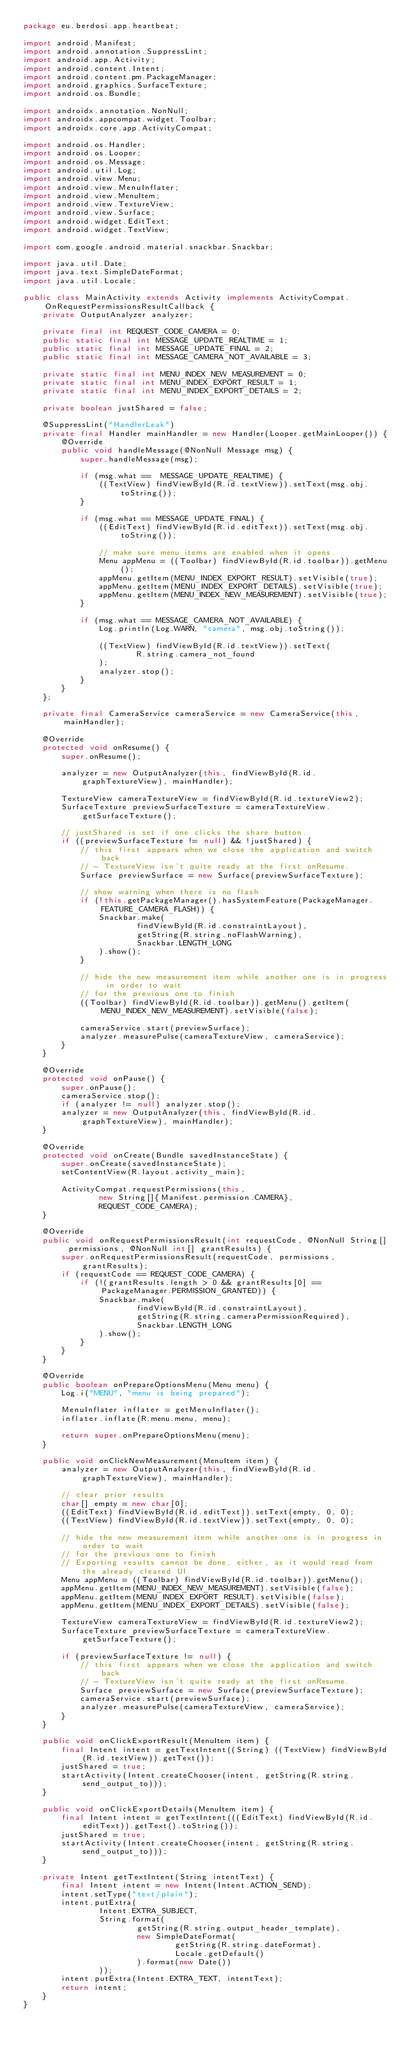<code> <loc_0><loc_0><loc_500><loc_500><_Java_>package eu.berdosi.app.heartbeat;

import android.Manifest;
import android.annotation.SuppressLint;
import android.app.Activity;
import android.content.Intent;
import android.content.pm.PackageManager;
import android.graphics.SurfaceTexture;
import android.os.Bundle;

import androidx.annotation.NonNull;
import androidx.appcompat.widget.Toolbar;
import androidx.core.app.ActivityCompat;

import android.os.Handler;
import android.os.Looper;
import android.os.Message;
import android.util.Log;
import android.view.Menu;
import android.view.MenuInflater;
import android.view.MenuItem;
import android.view.TextureView;
import android.view.Surface;
import android.widget.EditText;
import android.widget.TextView;

import com.google.android.material.snackbar.Snackbar;

import java.util.Date;
import java.text.SimpleDateFormat;
import java.util.Locale;

public class MainActivity extends Activity implements ActivityCompat.OnRequestPermissionsResultCallback {
    private OutputAnalyzer analyzer;

    private final int REQUEST_CODE_CAMERA = 0;
    public static final int MESSAGE_UPDATE_REALTIME = 1;
    public static final int MESSAGE_UPDATE_FINAL = 2;
    public static final int MESSAGE_CAMERA_NOT_AVAILABLE = 3;

    private static final int MENU_INDEX_NEW_MEASUREMENT = 0;
    private static final int MENU_INDEX_EXPORT_RESULT = 1;
    private static final int MENU_INDEX_EXPORT_DETAILS = 2;

    private boolean justShared = false;

    @SuppressLint("HandlerLeak")
    private final Handler mainHandler = new Handler(Looper.getMainLooper()) {
        @Override
        public void handleMessage(@NonNull Message msg) {
            super.handleMessage(msg);

            if (msg.what ==  MESSAGE_UPDATE_REALTIME) {
                ((TextView) findViewById(R.id.textView)).setText(msg.obj.toString());
            }

            if (msg.what == MESSAGE_UPDATE_FINAL) {
                ((EditText) findViewById(R.id.editText)).setText(msg.obj.toString());

                // make sure menu items are enabled when it opens.
                Menu appMenu = ((Toolbar) findViewById(R.id.toolbar)).getMenu();
                appMenu.getItem(MENU_INDEX_EXPORT_RESULT).setVisible(true);
                appMenu.getItem(MENU_INDEX_EXPORT_DETAILS).setVisible(true);
                appMenu.getItem(MENU_INDEX_NEW_MEASUREMENT).setVisible(true);
            }

            if (msg.what == MESSAGE_CAMERA_NOT_AVAILABLE) {
                Log.println(Log.WARN, "camera", msg.obj.toString());

                ((TextView) findViewById(R.id.textView)).setText(
                        R.string.camera_not_found
                );
                analyzer.stop();
            }
        }
    };

    private final CameraService cameraService = new CameraService(this, mainHandler);

    @Override
    protected void onResume() {
        super.onResume();

        analyzer = new OutputAnalyzer(this, findViewById(R.id.graphTextureView), mainHandler);

        TextureView cameraTextureView = findViewById(R.id.textureView2);
        SurfaceTexture previewSurfaceTexture = cameraTextureView.getSurfaceTexture();

        // justShared is set if one clicks the share button.
        if ((previewSurfaceTexture != null) && !justShared) {
            // this first appears when we close the application and switch back
            // - TextureView isn't quite ready at the first onResume.
            Surface previewSurface = new Surface(previewSurfaceTexture);

            // show warning when there is no flash
            if (!this.getPackageManager().hasSystemFeature(PackageManager.FEATURE_CAMERA_FLASH)) {
                Snackbar.make(
                        findViewById(R.id.constraintLayout),
                        getString(R.string.noFlashWarning),
                        Snackbar.LENGTH_LONG
                ).show();
            }

            // hide the new measurement item while another one is in progress in order to wait
            // for the previous one to finish
            ((Toolbar) findViewById(R.id.toolbar)).getMenu().getItem(MENU_INDEX_NEW_MEASUREMENT).setVisible(false);

            cameraService.start(previewSurface);
            analyzer.measurePulse(cameraTextureView, cameraService);
        }
    }

    @Override
    protected void onPause() {
        super.onPause();
        cameraService.stop();
        if (analyzer != null) analyzer.stop();
        analyzer = new OutputAnalyzer(this, findViewById(R.id.graphTextureView), mainHandler);
    }

    @Override
    protected void onCreate(Bundle savedInstanceState) {
        super.onCreate(savedInstanceState);
        setContentView(R.layout.activity_main);

        ActivityCompat.requestPermissions(this,
                new String[]{Manifest.permission.CAMERA},
                REQUEST_CODE_CAMERA);
    }

    @Override
    public void onRequestPermissionsResult(int requestCode, @NonNull String[] permissions, @NonNull int[] grantResults) {
        super.onRequestPermissionsResult(requestCode, permissions, grantResults);
        if (requestCode == REQUEST_CODE_CAMERA) {
            if (!(grantResults.length > 0 && grantResults[0] == PackageManager.PERMISSION_GRANTED)) {
                Snackbar.make(
                        findViewById(R.id.constraintLayout),
                        getString(R.string.cameraPermissionRequired),
                        Snackbar.LENGTH_LONG
                ).show();
            }
        }
    }

    @Override
    public boolean onPrepareOptionsMenu(Menu menu) {
        Log.i("MENU", "menu is being prepared");

        MenuInflater inflater = getMenuInflater();
        inflater.inflate(R.menu.menu, menu);

        return super.onPrepareOptionsMenu(menu);
    }

    public void onClickNewMeasurement(MenuItem item) {
        analyzer = new OutputAnalyzer(this, findViewById(R.id.graphTextureView), mainHandler);

        // clear prior results
        char[] empty = new char[0];
        ((EditText) findViewById(R.id.editText)).setText(empty, 0, 0);
        ((TextView) findViewById(R.id.textView)).setText(empty, 0, 0);

        // hide the new measurement item while another one is in progress in order to wait
        // for the previous one to finish
        // Exporting results cannot be done, either, as it would read from the already cleared UI.
        Menu appMenu = ((Toolbar) findViewById(R.id.toolbar)).getMenu();
        appMenu.getItem(MENU_INDEX_NEW_MEASUREMENT).setVisible(false);
        appMenu.getItem(MENU_INDEX_EXPORT_RESULT).setVisible(false);
        appMenu.getItem(MENU_INDEX_EXPORT_DETAILS).setVisible(false);

        TextureView cameraTextureView = findViewById(R.id.textureView2);
        SurfaceTexture previewSurfaceTexture = cameraTextureView.getSurfaceTexture();

        if (previewSurfaceTexture != null) {
            // this first appears when we close the application and switch back
            // - TextureView isn't quite ready at the first onResume.
            Surface previewSurface = new Surface(previewSurfaceTexture);
            cameraService.start(previewSurface);
            analyzer.measurePulse(cameraTextureView, cameraService);
        }
    }

    public void onClickExportResult(MenuItem item) {
        final Intent intent = getTextIntent((String) ((TextView) findViewById(R.id.textView)).getText());
        justShared = true;
        startActivity(Intent.createChooser(intent, getString(R.string.send_output_to)));
    }

    public void onClickExportDetails(MenuItem item) {
        final Intent intent = getTextIntent(((EditText) findViewById(R.id.editText)).getText().toString());
        justShared = true;
        startActivity(Intent.createChooser(intent, getString(R.string.send_output_to)));
    }

    private Intent getTextIntent(String intentText) {
        final Intent intent = new Intent(Intent.ACTION_SEND);
        intent.setType("text/plain");
        intent.putExtra(
                Intent.EXTRA_SUBJECT,
                String.format(
                        getString(R.string.output_header_template),
                        new SimpleDateFormat(
                                getString(R.string.dateFormat),
                                Locale.getDefault()
                        ).format(new Date())
                ));
        intent.putExtra(Intent.EXTRA_TEXT, intentText);
        return intent;
    }
}
</code> 